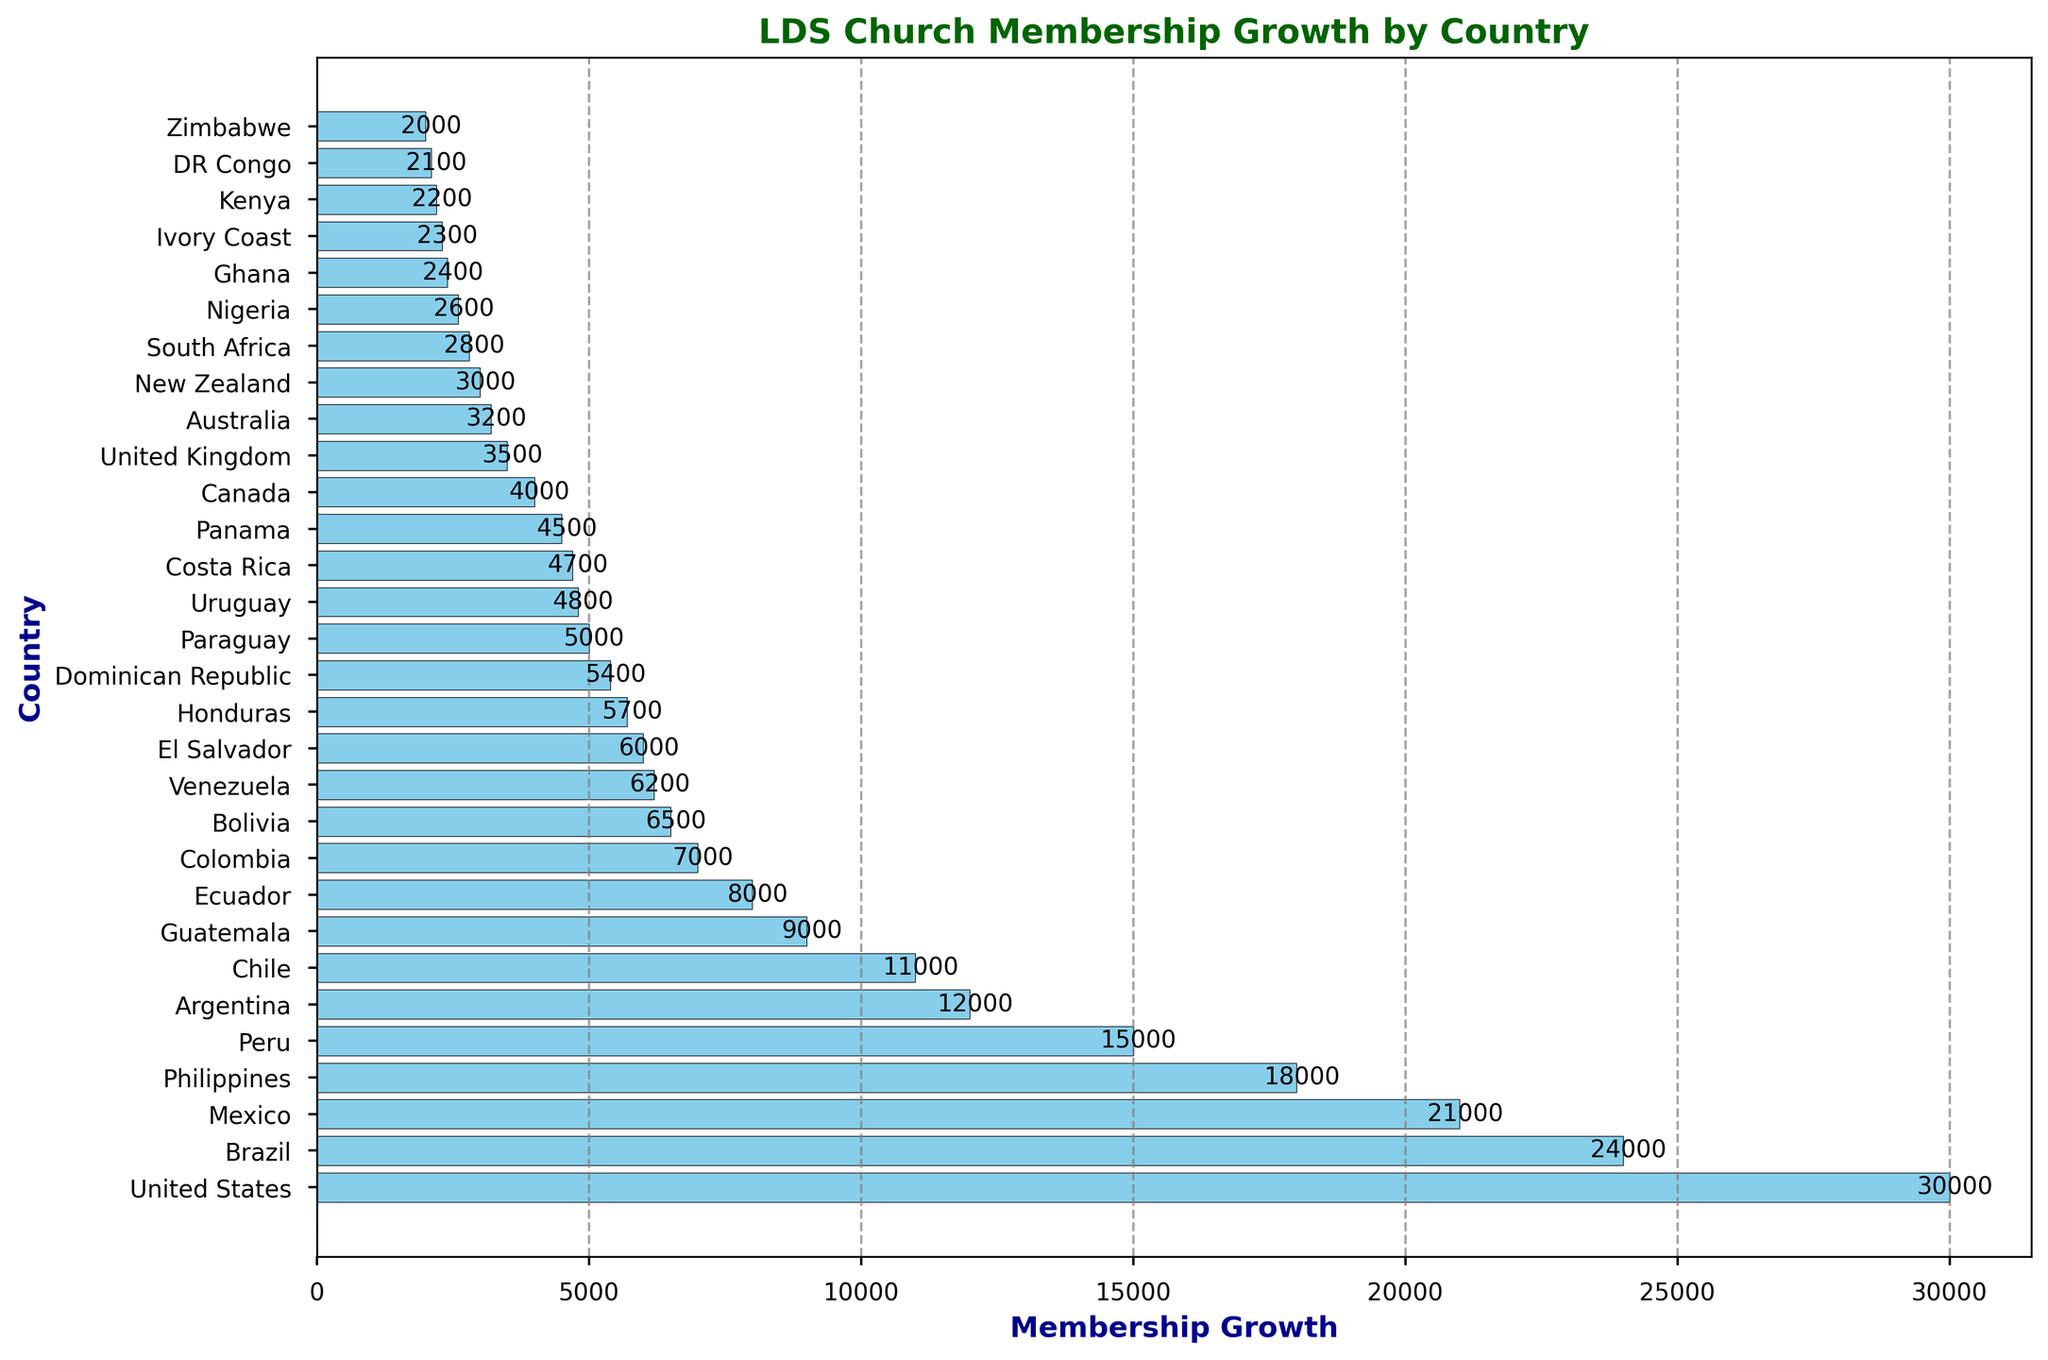Which country has the highest membership growth in the LDS Church? By looking at the length of the bars, the United States has the longest bar, indicating the highest membership growth.
Answer: United States Which country, between Brazil and Mexico, has higher membership growth? By comparing the lengths of the bars for Brazil and Mexico, Brazil has a longer bar, indicating higher membership growth compared to Mexico.
Answer: Brazil What is the combined membership growth of Philippines, Peru, and Argentina? Sum the values for these countries: 18000 (Philippines) + 15000 (Peru) + 12000 (Argentina) = 45000
Answer: 45000 How many countries have a membership growth greater than 5000 but less than 10000? From the figure, countries with membership growth within this range are Guatemala, Ecuador, Colombia, Bolivia, Venezuela, El Salvador, Honduras, Dominican Republic, Paraguay, Uruguay, Costa Rica, and Panama. Counting these countries gives us 12.
Answer: 12 What is the membership growth difference between Venezuela and Costa Rica? Subtract the membership growth of Costa Rica from Venezuela: 6200 (Venezuela) - 4700 (Costa Rica) = 1500
Answer: 1500 Which countries have a membership growth of exactly 3000? By looking at the figure, New Zealand has a membership growth of 3000.
Answer: New Zealand What are the first three countries to the right of the y-axis with the highest membership growth? The first three bars from the top, which are the longest, represent the countries with the highest membership growth: United States, Brazil, and Mexico, respectively.
Answer: United States, Brazil, Mexico Compare the membership growth of Nigeria and Ghana. Which is greater? And by how much? Nigeria has a membership growth of 2600, while Ghana has 2400. The difference is 2600 - 2400 = 200.
Answer: Nigeria by 200 What is the average membership growth for all countries shown in the figure? Sum all the membership growth values and divide by the number of countries: (30000 + 24000 + 21000 + ... + 2000) / 30. The total sum is 222200 and the number of countries is 30, so the average is 222200 / 30 = 7406.67
Answer: 7406.67 